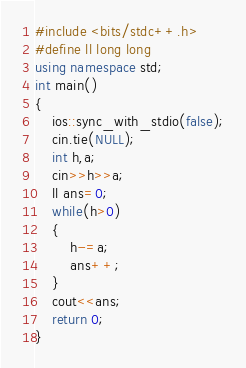Convert code to text. <code><loc_0><loc_0><loc_500><loc_500><_C++_>#include <bits/stdc++.h>
#define ll long long
using namespace std;
int main()
{
    ios::sync_with_stdio(false);
    cin.tie(NULL);
    int h,a;
    cin>>h>>a;
    ll ans=0;
    while(h>0)
    {
        h-=a;
        ans++;
    }
    cout<<ans;
    return 0;
}







</code> 